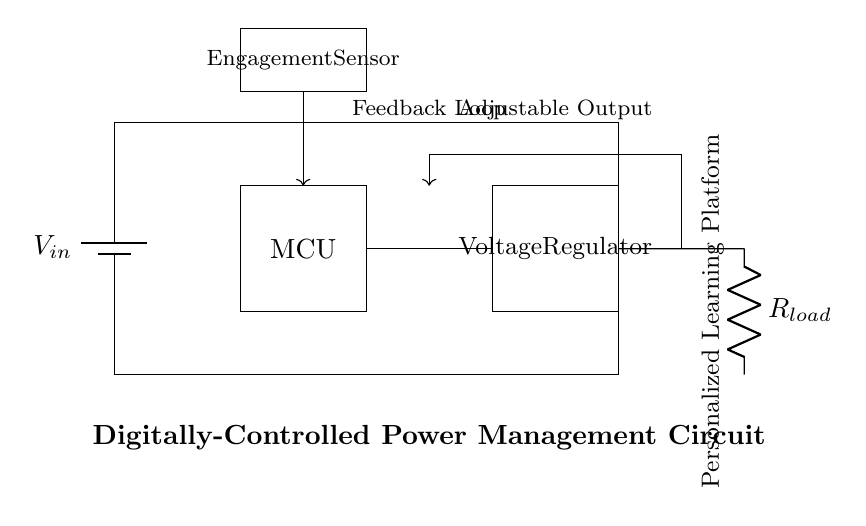What is the input voltage source? The input voltage source is labeled as V_in, indicating the voltage supplied to the circuit.
Answer: V_in What is the purpose of the microcontroller? The microcontroller, labeled MCU, is responsible for controlling the operation of the circuit, specifically adjusting the power based on the engagement sensor.
Answer: Control What type of load is used at the output? The load at the output is represented by R_load, which indicates a resistive load typically found in power management circuits.
Answer: Resistor How does the engagement sensor communicate with the rest of the circuit? The engagement sensor sends feedback to the microcontroller through a direct connection, indicated by the arrow pointing from the sensor to the MCU. This communication allows for adjustments in power based on user engagement.
Answer: Direct connection What is the role of the feedback loop in this circuit? The feedback loop is used to adjust the voltage output based on the engagement of the user. The sensor sends feedback to the microcontroller, which regulates the voltage from the voltage regulator to ensure optimal performance.
Answer: Adjust voltage What type of voltage adjustment does this circuit perform? The circuit utilizes a voltage regulator to maintain a stable output voltage that can be adjusted dynamically through the feedback provided by the engagement sensor.
Answer: Dynamic regulation What is the annotation for the output of the regulator? The output of the regulator is connected to R_load, indicating that the output is delivering power to the load specified.
Answer: R_load 